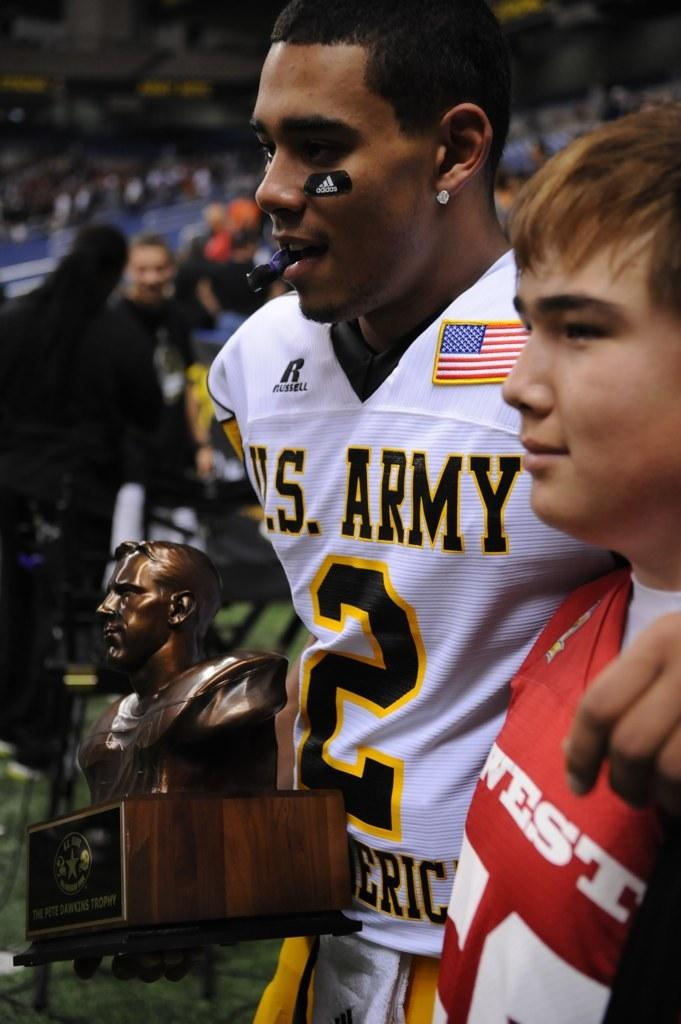Provide a one-sentence caption for the provided image. a football player for the US army holding a trophy. 